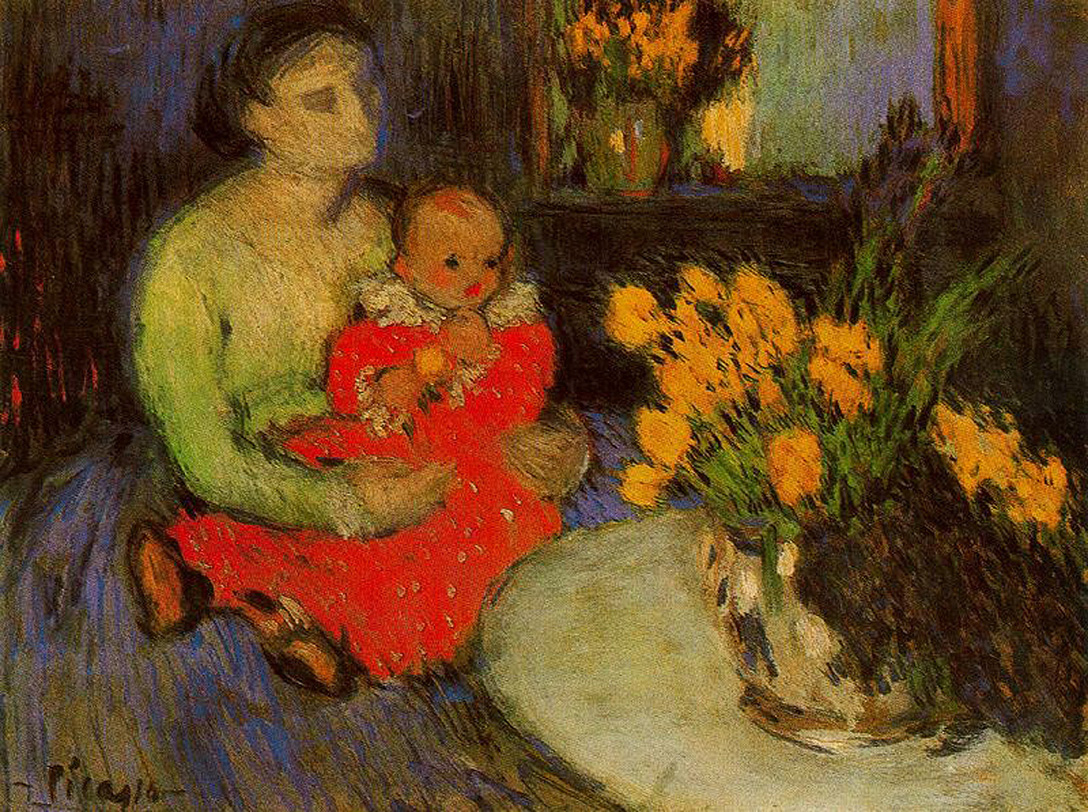How does the artist's use of light influence the mood of the painting? The artist's use of light plays a pivotal role in setting the mood of this painting. The dim lighting contrasts sharply with the bright attire of the mother and child, creating a cozy and intimate atmosphere. This contrast not only emphasizes the bond between the figures but also guides the viewer’s focus towards the subjects. The subtle lighting on the flowers in the background adds a touch of warmth to the overall scene, making it feel both serene and comforting. 